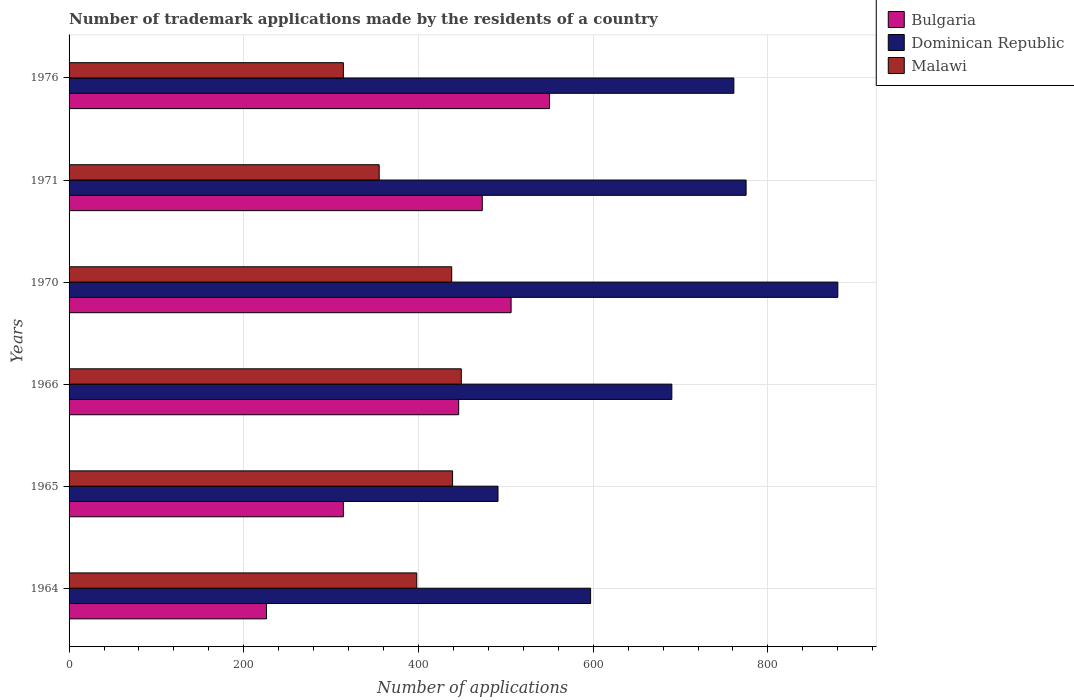How many different coloured bars are there?
Offer a terse response. 3. Are the number of bars per tick equal to the number of legend labels?
Offer a terse response. Yes. How many bars are there on the 5th tick from the top?
Ensure brevity in your answer.  3. How many bars are there on the 6th tick from the bottom?
Your answer should be compact. 3. What is the number of trademark applications made by the residents in Dominican Republic in 1971?
Ensure brevity in your answer.  775. Across all years, what is the maximum number of trademark applications made by the residents in Malawi?
Your answer should be very brief. 449. Across all years, what is the minimum number of trademark applications made by the residents in Malawi?
Give a very brief answer. 314. In which year was the number of trademark applications made by the residents in Malawi maximum?
Make the answer very short. 1966. In which year was the number of trademark applications made by the residents in Bulgaria minimum?
Your response must be concise. 1964. What is the total number of trademark applications made by the residents in Bulgaria in the graph?
Make the answer very short. 2515. What is the difference between the number of trademark applications made by the residents in Bulgaria in 1964 and the number of trademark applications made by the residents in Dominican Republic in 1966?
Your answer should be very brief. -464. What is the average number of trademark applications made by the residents in Malawi per year?
Ensure brevity in your answer.  398.83. In the year 1970, what is the difference between the number of trademark applications made by the residents in Dominican Republic and number of trademark applications made by the residents in Bulgaria?
Ensure brevity in your answer.  374. In how many years, is the number of trademark applications made by the residents in Malawi greater than 800 ?
Your answer should be compact. 0. What is the ratio of the number of trademark applications made by the residents in Malawi in 1965 to that in 1976?
Your response must be concise. 1.4. Is the difference between the number of trademark applications made by the residents in Dominican Republic in 1965 and 1966 greater than the difference between the number of trademark applications made by the residents in Bulgaria in 1965 and 1966?
Make the answer very short. No. What is the difference between the highest and the second highest number of trademark applications made by the residents in Dominican Republic?
Offer a terse response. 105. What is the difference between the highest and the lowest number of trademark applications made by the residents in Malawi?
Your answer should be very brief. 135. In how many years, is the number of trademark applications made by the residents in Malawi greater than the average number of trademark applications made by the residents in Malawi taken over all years?
Ensure brevity in your answer.  3. What does the 3rd bar from the top in 1976 represents?
Keep it short and to the point. Bulgaria. Is it the case that in every year, the sum of the number of trademark applications made by the residents in Malawi and number of trademark applications made by the residents in Dominican Republic is greater than the number of trademark applications made by the residents in Bulgaria?
Ensure brevity in your answer.  Yes. How many bars are there?
Offer a terse response. 18. What is the difference between two consecutive major ticks on the X-axis?
Ensure brevity in your answer.  200. Are the values on the major ticks of X-axis written in scientific E-notation?
Offer a terse response. No. Does the graph contain grids?
Your answer should be compact. Yes. Where does the legend appear in the graph?
Keep it short and to the point. Top right. How many legend labels are there?
Offer a terse response. 3. How are the legend labels stacked?
Make the answer very short. Vertical. What is the title of the graph?
Ensure brevity in your answer.  Number of trademark applications made by the residents of a country. Does "Kosovo" appear as one of the legend labels in the graph?
Make the answer very short. No. What is the label or title of the X-axis?
Make the answer very short. Number of applications. What is the label or title of the Y-axis?
Your response must be concise. Years. What is the Number of applications of Bulgaria in 1964?
Your answer should be very brief. 226. What is the Number of applications of Dominican Republic in 1964?
Offer a terse response. 597. What is the Number of applications of Malawi in 1964?
Make the answer very short. 398. What is the Number of applications of Bulgaria in 1965?
Make the answer very short. 314. What is the Number of applications in Dominican Republic in 1965?
Provide a short and direct response. 491. What is the Number of applications of Malawi in 1965?
Provide a succinct answer. 439. What is the Number of applications in Bulgaria in 1966?
Make the answer very short. 446. What is the Number of applications in Dominican Republic in 1966?
Offer a terse response. 690. What is the Number of applications in Malawi in 1966?
Keep it short and to the point. 449. What is the Number of applications in Bulgaria in 1970?
Keep it short and to the point. 506. What is the Number of applications in Dominican Republic in 1970?
Your answer should be very brief. 880. What is the Number of applications of Malawi in 1970?
Offer a very short reply. 438. What is the Number of applications of Bulgaria in 1971?
Provide a short and direct response. 473. What is the Number of applications in Dominican Republic in 1971?
Offer a terse response. 775. What is the Number of applications of Malawi in 1971?
Offer a very short reply. 355. What is the Number of applications of Bulgaria in 1976?
Your response must be concise. 550. What is the Number of applications of Dominican Republic in 1976?
Give a very brief answer. 761. What is the Number of applications of Malawi in 1976?
Your answer should be compact. 314. Across all years, what is the maximum Number of applications of Bulgaria?
Make the answer very short. 550. Across all years, what is the maximum Number of applications in Dominican Republic?
Your response must be concise. 880. Across all years, what is the maximum Number of applications of Malawi?
Provide a succinct answer. 449. Across all years, what is the minimum Number of applications in Bulgaria?
Give a very brief answer. 226. Across all years, what is the minimum Number of applications in Dominican Republic?
Your answer should be compact. 491. Across all years, what is the minimum Number of applications in Malawi?
Keep it short and to the point. 314. What is the total Number of applications in Bulgaria in the graph?
Give a very brief answer. 2515. What is the total Number of applications of Dominican Republic in the graph?
Ensure brevity in your answer.  4194. What is the total Number of applications in Malawi in the graph?
Provide a short and direct response. 2393. What is the difference between the Number of applications in Bulgaria in 1964 and that in 1965?
Your answer should be compact. -88. What is the difference between the Number of applications in Dominican Republic in 1964 and that in 1965?
Offer a terse response. 106. What is the difference between the Number of applications in Malawi in 1964 and that in 1965?
Your response must be concise. -41. What is the difference between the Number of applications in Bulgaria in 1964 and that in 1966?
Keep it short and to the point. -220. What is the difference between the Number of applications in Dominican Republic in 1964 and that in 1966?
Give a very brief answer. -93. What is the difference between the Number of applications in Malawi in 1964 and that in 1966?
Provide a short and direct response. -51. What is the difference between the Number of applications in Bulgaria in 1964 and that in 1970?
Your response must be concise. -280. What is the difference between the Number of applications of Dominican Republic in 1964 and that in 1970?
Ensure brevity in your answer.  -283. What is the difference between the Number of applications of Bulgaria in 1964 and that in 1971?
Ensure brevity in your answer.  -247. What is the difference between the Number of applications in Dominican Republic in 1964 and that in 1971?
Make the answer very short. -178. What is the difference between the Number of applications of Bulgaria in 1964 and that in 1976?
Give a very brief answer. -324. What is the difference between the Number of applications of Dominican Republic in 1964 and that in 1976?
Offer a very short reply. -164. What is the difference between the Number of applications in Malawi in 1964 and that in 1976?
Offer a terse response. 84. What is the difference between the Number of applications of Bulgaria in 1965 and that in 1966?
Ensure brevity in your answer.  -132. What is the difference between the Number of applications in Dominican Republic in 1965 and that in 1966?
Keep it short and to the point. -199. What is the difference between the Number of applications of Malawi in 1965 and that in 1966?
Provide a short and direct response. -10. What is the difference between the Number of applications in Bulgaria in 1965 and that in 1970?
Ensure brevity in your answer.  -192. What is the difference between the Number of applications of Dominican Republic in 1965 and that in 1970?
Provide a short and direct response. -389. What is the difference between the Number of applications of Bulgaria in 1965 and that in 1971?
Ensure brevity in your answer.  -159. What is the difference between the Number of applications of Dominican Republic in 1965 and that in 1971?
Offer a very short reply. -284. What is the difference between the Number of applications in Bulgaria in 1965 and that in 1976?
Offer a terse response. -236. What is the difference between the Number of applications in Dominican Republic in 1965 and that in 1976?
Provide a short and direct response. -270. What is the difference between the Number of applications of Malawi in 1965 and that in 1976?
Provide a succinct answer. 125. What is the difference between the Number of applications in Bulgaria in 1966 and that in 1970?
Give a very brief answer. -60. What is the difference between the Number of applications of Dominican Republic in 1966 and that in 1970?
Your answer should be compact. -190. What is the difference between the Number of applications of Bulgaria in 1966 and that in 1971?
Provide a succinct answer. -27. What is the difference between the Number of applications of Dominican Republic in 1966 and that in 1971?
Keep it short and to the point. -85. What is the difference between the Number of applications in Malawi in 1966 and that in 1971?
Offer a terse response. 94. What is the difference between the Number of applications of Bulgaria in 1966 and that in 1976?
Your answer should be very brief. -104. What is the difference between the Number of applications of Dominican Republic in 1966 and that in 1976?
Provide a short and direct response. -71. What is the difference between the Number of applications in Malawi in 1966 and that in 1976?
Make the answer very short. 135. What is the difference between the Number of applications of Bulgaria in 1970 and that in 1971?
Make the answer very short. 33. What is the difference between the Number of applications of Dominican Republic in 1970 and that in 1971?
Make the answer very short. 105. What is the difference between the Number of applications in Bulgaria in 1970 and that in 1976?
Make the answer very short. -44. What is the difference between the Number of applications in Dominican Republic in 1970 and that in 1976?
Make the answer very short. 119. What is the difference between the Number of applications of Malawi in 1970 and that in 1976?
Make the answer very short. 124. What is the difference between the Number of applications in Bulgaria in 1971 and that in 1976?
Your answer should be very brief. -77. What is the difference between the Number of applications in Dominican Republic in 1971 and that in 1976?
Your response must be concise. 14. What is the difference between the Number of applications in Malawi in 1971 and that in 1976?
Your answer should be compact. 41. What is the difference between the Number of applications of Bulgaria in 1964 and the Number of applications of Dominican Republic in 1965?
Offer a very short reply. -265. What is the difference between the Number of applications in Bulgaria in 1964 and the Number of applications in Malawi in 1965?
Offer a terse response. -213. What is the difference between the Number of applications of Dominican Republic in 1964 and the Number of applications of Malawi in 1965?
Provide a short and direct response. 158. What is the difference between the Number of applications in Bulgaria in 1964 and the Number of applications in Dominican Republic in 1966?
Your answer should be very brief. -464. What is the difference between the Number of applications of Bulgaria in 1964 and the Number of applications of Malawi in 1966?
Your answer should be compact. -223. What is the difference between the Number of applications of Dominican Republic in 1964 and the Number of applications of Malawi in 1966?
Ensure brevity in your answer.  148. What is the difference between the Number of applications of Bulgaria in 1964 and the Number of applications of Dominican Republic in 1970?
Ensure brevity in your answer.  -654. What is the difference between the Number of applications of Bulgaria in 1964 and the Number of applications of Malawi in 1970?
Make the answer very short. -212. What is the difference between the Number of applications in Dominican Republic in 1964 and the Number of applications in Malawi in 1970?
Offer a very short reply. 159. What is the difference between the Number of applications in Bulgaria in 1964 and the Number of applications in Dominican Republic in 1971?
Provide a succinct answer. -549. What is the difference between the Number of applications of Bulgaria in 1964 and the Number of applications of Malawi in 1971?
Ensure brevity in your answer.  -129. What is the difference between the Number of applications of Dominican Republic in 1964 and the Number of applications of Malawi in 1971?
Offer a very short reply. 242. What is the difference between the Number of applications in Bulgaria in 1964 and the Number of applications in Dominican Republic in 1976?
Provide a short and direct response. -535. What is the difference between the Number of applications in Bulgaria in 1964 and the Number of applications in Malawi in 1976?
Your response must be concise. -88. What is the difference between the Number of applications of Dominican Republic in 1964 and the Number of applications of Malawi in 1976?
Provide a succinct answer. 283. What is the difference between the Number of applications of Bulgaria in 1965 and the Number of applications of Dominican Republic in 1966?
Your answer should be very brief. -376. What is the difference between the Number of applications of Bulgaria in 1965 and the Number of applications of Malawi in 1966?
Keep it short and to the point. -135. What is the difference between the Number of applications in Bulgaria in 1965 and the Number of applications in Dominican Republic in 1970?
Make the answer very short. -566. What is the difference between the Number of applications in Bulgaria in 1965 and the Number of applications in Malawi in 1970?
Your response must be concise. -124. What is the difference between the Number of applications of Bulgaria in 1965 and the Number of applications of Dominican Republic in 1971?
Give a very brief answer. -461. What is the difference between the Number of applications of Bulgaria in 1965 and the Number of applications of Malawi in 1971?
Offer a very short reply. -41. What is the difference between the Number of applications of Dominican Republic in 1965 and the Number of applications of Malawi in 1971?
Provide a short and direct response. 136. What is the difference between the Number of applications of Bulgaria in 1965 and the Number of applications of Dominican Republic in 1976?
Give a very brief answer. -447. What is the difference between the Number of applications in Dominican Republic in 1965 and the Number of applications in Malawi in 1976?
Your answer should be very brief. 177. What is the difference between the Number of applications of Bulgaria in 1966 and the Number of applications of Dominican Republic in 1970?
Make the answer very short. -434. What is the difference between the Number of applications in Bulgaria in 1966 and the Number of applications in Malawi in 1970?
Provide a short and direct response. 8. What is the difference between the Number of applications of Dominican Republic in 1966 and the Number of applications of Malawi in 1970?
Ensure brevity in your answer.  252. What is the difference between the Number of applications in Bulgaria in 1966 and the Number of applications in Dominican Republic in 1971?
Your response must be concise. -329. What is the difference between the Number of applications in Bulgaria in 1966 and the Number of applications in Malawi in 1971?
Your answer should be very brief. 91. What is the difference between the Number of applications in Dominican Republic in 1966 and the Number of applications in Malawi in 1971?
Your answer should be very brief. 335. What is the difference between the Number of applications in Bulgaria in 1966 and the Number of applications in Dominican Republic in 1976?
Provide a succinct answer. -315. What is the difference between the Number of applications in Bulgaria in 1966 and the Number of applications in Malawi in 1976?
Offer a terse response. 132. What is the difference between the Number of applications in Dominican Republic in 1966 and the Number of applications in Malawi in 1976?
Provide a succinct answer. 376. What is the difference between the Number of applications of Bulgaria in 1970 and the Number of applications of Dominican Republic in 1971?
Keep it short and to the point. -269. What is the difference between the Number of applications in Bulgaria in 1970 and the Number of applications in Malawi in 1971?
Your response must be concise. 151. What is the difference between the Number of applications of Dominican Republic in 1970 and the Number of applications of Malawi in 1971?
Provide a short and direct response. 525. What is the difference between the Number of applications in Bulgaria in 1970 and the Number of applications in Dominican Republic in 1976?
Keep it short and to the point. -255. What is the difference between the Number of applications in Bulgaria in 1970 and the Number of applications in Malawi in 1976?
Your answer should be compact. 192. What is the difference between the Number of applications of Dominican Republic in 1970 and the Number of applications of Malawi in 1976?
Offer a very short reply. 566. What is the difference between the Number of applications of Bulgaria in 1971 and the Number of applications of Dominican Republic in 1976?
Your response must be concise. -288. What is the difference between the Number of applications of Bulgaria in 1971 and the Number of applications of Malawi in 1976?
Give a very brief answer. 159. What is the difference between the Number of applications of Dominican Republic in 1971 and the Number of applications of Malawi in 1976?
Make the answer very short. 461. What is the average Number of applications of Bulgaria per year?
Your answer should be very brief. 419.17. What is the average Number of applications in Dominican Republic per year?
Ensure brevity in your answer.  699. What is the average Number of applications in Malawi per year?
Offer a terse response. 398.83. In the year 1964, what is the difference between the Number of applications of Bulgaria and Number of applications of Dominican Republic?
Provide a succinct answer. -371. In the year 1964, what is the difference between the Number of applications in Bulgaria and Number of applications in Malawi?
Your answer should be compact. -172. In the year 1964, what is the difference between the Number of applications in Dominican Republic and Number of applications in Malawi?
Offer a terse response. 199. In the year 1965, what is the difference between the Number of applications in Bulgaria and Number of applications in Dominican Republic?
Your answer should be very brief. -177. In the year 1965, what is the difference between the Number of applications in Bulgaria and Number of applications in Malawi?
Your answer should be compact. -125. In the year 1965, what is the difference between the Number of applications of Dominican Republic and Number of applications of Malawi?
Provide a short and direct response. 52. In the year 1966, what is the difference between the Number of applications of Bulgaria and Number of applications of Dominican Republic?
Offer a terse response. -244. In the year 1966, what is the difference between the Number of applications in Dominican Republic and Number of applications in Malawi?
Offer a terse response. 241. In the year 1970, what is the difference between the Number of applications in Bulgaria and Number of applications in Dominican Republic?
Provide a succinct answer. -374. In the year 1970, what is the difference between the Number of applications of Bulgaria and Number of applications of Malawi?
Make the answer very short. 68. In the year 1970, what is the difference between the Number of applications in Dominican Republic and Number of applications in Malawi?
Make the answer very short. 442. In the year 1971, what is the difference between the Number of applications of Bulgaria and Number of applications of Dominican Republic?
Offer a terse response. -302. In the year 1971, what is the difference between the Number of applications in Bulgaria and Number of applications in Malawi?
Your response must be concise. 118. In the year 1971, what is the difference between the Number of applications of Dominican Republic and Number of applications of Malawi?
Ensure brevity in your answer.  420. In the year 1976, what is the difference between the Number of applications of Bulgaria and Number of applications of Dominican Republic?
Offer a very short reply. -211. In the year 1976, what is the difference between the Number of applications in Bulgaria and Number of applications in Malawi?
Keep it short and to the point. 236. In the year 1976, what is the difference between the Number of applications of Dominican Republic and Number of applications of Malawi?
Your answer should be compact. 447. What is the ratio of the Number of applications in Bulgaria in 1964 to that in 1965?
Your response must be concise. 0.72. What is the ratio of the Number of applications in Dominican Republic in 1964 to that in 1965?
Your response must be concise. 1.22. What is the ratio of the Number of applications of Malawi in 1964 to that in 1965?
Ensure brevity in your answer.  0.91. What is the ratio of the Number of applications of Bulgaria in 1964 to that in 1966?
Offer a terse response. 0.51. What is the ratio of the Number of applications in Dominican Republic in 1964 to that in 1966?
Ensure brevity in your answer.  0.87. What is the ratio of the Number of applications in Malawi in 1964 to that in 1966?
Offer a very short reply. 0.89. What is the ratio of the Number of applications of Bulgaria in 1964 to that in 1970?
Give a very brief answer. 0.45. What is the ratio of the Number of applications of Dominican Republic in 1964 to that in 1970?
Your response must be concise. 0.68. What is the ratio of the Number of applications in Malawi in 1964 to that in 1970?
Your answer should be very brief. 0.91. What is the ratio of the Number of applications in Bulgaria in 1964 to that in 1971?
Offer a very short reply. 0.48. What is the ratio of the Number of applications of Dominican Republic in 1964 to that in 1971?
Ensure brevity in your answer.  0.77. What is the ratio of the Number of applications of Malawi in 1964 to that in 1971?
Offer a very short reply. 1.12. What is the ratio of the Number of applications in Bulgaria in 1964 to that in 1976?
Your answer should be very brief. 0.41. What is the ratio of the Number of applications of Dominican Republic in 1964 to that in 1976?
Make the answer very short. 0.78. What is the ratio of the Number of applications in Malawi in 1964 to that in 1976?
Provide a short and direct response. 1.27. What is the ratio of the Number of applications of Bulgaria in 1965 to that in 1966?
Provide a succinct answer. 0.7. What is the ratio of the Number of applications in Dominican Republic in 1965 to that in 1966?
Your answer should be very brief. 0.71. What is the ratio of the Number of applications of Malawi in 1965 to that in 1966?
Your response must be concise. 0.98. What is the ratio of the Number of applications in Bulgaria in 1965 to that in 1970?
Provide a succinct answer. 0.62. What is the ratio of the Number of applications of Dominican Republic in 1965 to that in 1970?
Make the answer very short. 0.56. What is the ratio of the Number of applications of Bulgaria in 1965 to that in 1971?
Your answer should be compact. 0.66. What is the ratio of the Number of applications in Dominican Republic in 1965 to that in 1971?
Your response must be concise. 0.63. What is the ratio of the Number of applications of Malawi in 1965 to that in 1971?
Make the answer very short. 1.24. What is the ratio of the Number of applications in Bulgaria in 1965 to that in 1976?
Your response must be concise. 0.57. What is the ratio of the Number of applications of Dominican Republic in 1965 to that in 1976?
Keep it short and to the point. 0.65. What is the ratio of the Number of applications of Malawi in 1965 to that in 1976?
Make the answer very short. 1.4. What is the ratio of the Number of applications of Bulgaria in 1966 to that in 1970?
Your answer should be compact. 0.88. What is the ratio of the Number of applications of Dominican Republic in 1966 to that in 1970?
Your answer should be compact. 0.78. What is the ratio of the Number of applications of Malawi in 1966 to that in 1970?
Make the answer very short. 1.03. What is the ratio of the Number of applications in Bulgaria in 1966 to that in 1971?
Keep it short and to the point. 0.94. What is the ratio of the Number of applications of Dominican Republic in 1966 to that in 1971?
Your answer should be very brief. 0.89. What is the ratio of the Number of applications in Malawi in 1966 to that in 1971?
Offer a terse response. 1.26. What is the ratio of the Number of applications in Bulgaria in 1966 to that in 1976?
Offer a terse response. 0.81. What is the ratio of the Number of applications in Dominican Republic in 1966 to that in 1976?
Your answer should be compact. 0.91. What is the ratio of the Number of applications of Malawi in 1966 to that in 1976?
Make the answer very short. 1.43. What is the ratio of the Number of applications of Bulgaria in 1970 to that in 1971?
Keep it short and to the point. 1.07. What is the ratio of the Number of applications in Dominican Republic in 1970 to that in 1971?
Offer a terse response. 1.14. What is the ratio of the Number of applications of Malawi in 1970 to that in 1971?
Offer a very short reply. 1.23. What is the ratio of the Number of applications in Bulgaria in 1970 to that in 1976?
Ensure brevity in your answer.  0.92. What is the ratio of the Number of applications in Dominican Republic in 1970 to that in 1976?
Give a very brief answer. 1.16. What is the ratio of the Number of applications in Malawi in 1970 to that in 1976?
Your answer should be compact. 1.39. What is the ratio of the Number of applications of Bulgaria in 1971 to that in 1976?
Provide a short and direct response. 0.86. What is the ratio of the Number of applications of Dominican Republic in 1971 to that in 1976?
Your answer should be compact. 1.02. What is the ratio of the Number of applications in Malawi in 1971 to that in 1976?
Make the answer very short. 1.13. What is the difference between the highest and the second highest Number of applications in Bulgaria?
Your response must be concise. 44. What is the difference between the highest and the second highest Number of applications of Dominican Republic?
Offer a very short reply. 105. What is the difference between the highest and the lowest Number of applications of Bulgaria?
Your answer should be very brief. 324. What is the difference between the highest and the lowest Number of applications of Dominican Republic?
Your answer should be very brief. 389. What is the difference between the highest and the lowest Number of applications in Malawi?
Give a very brief answer. 135. 